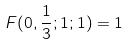Convert formula to latex. <formula><loc_0><loc_0><loc_500><loc_500>F ( 0 , \frac { 1 } { 3 } ; 1 ; 1 ) = 1</formula> 